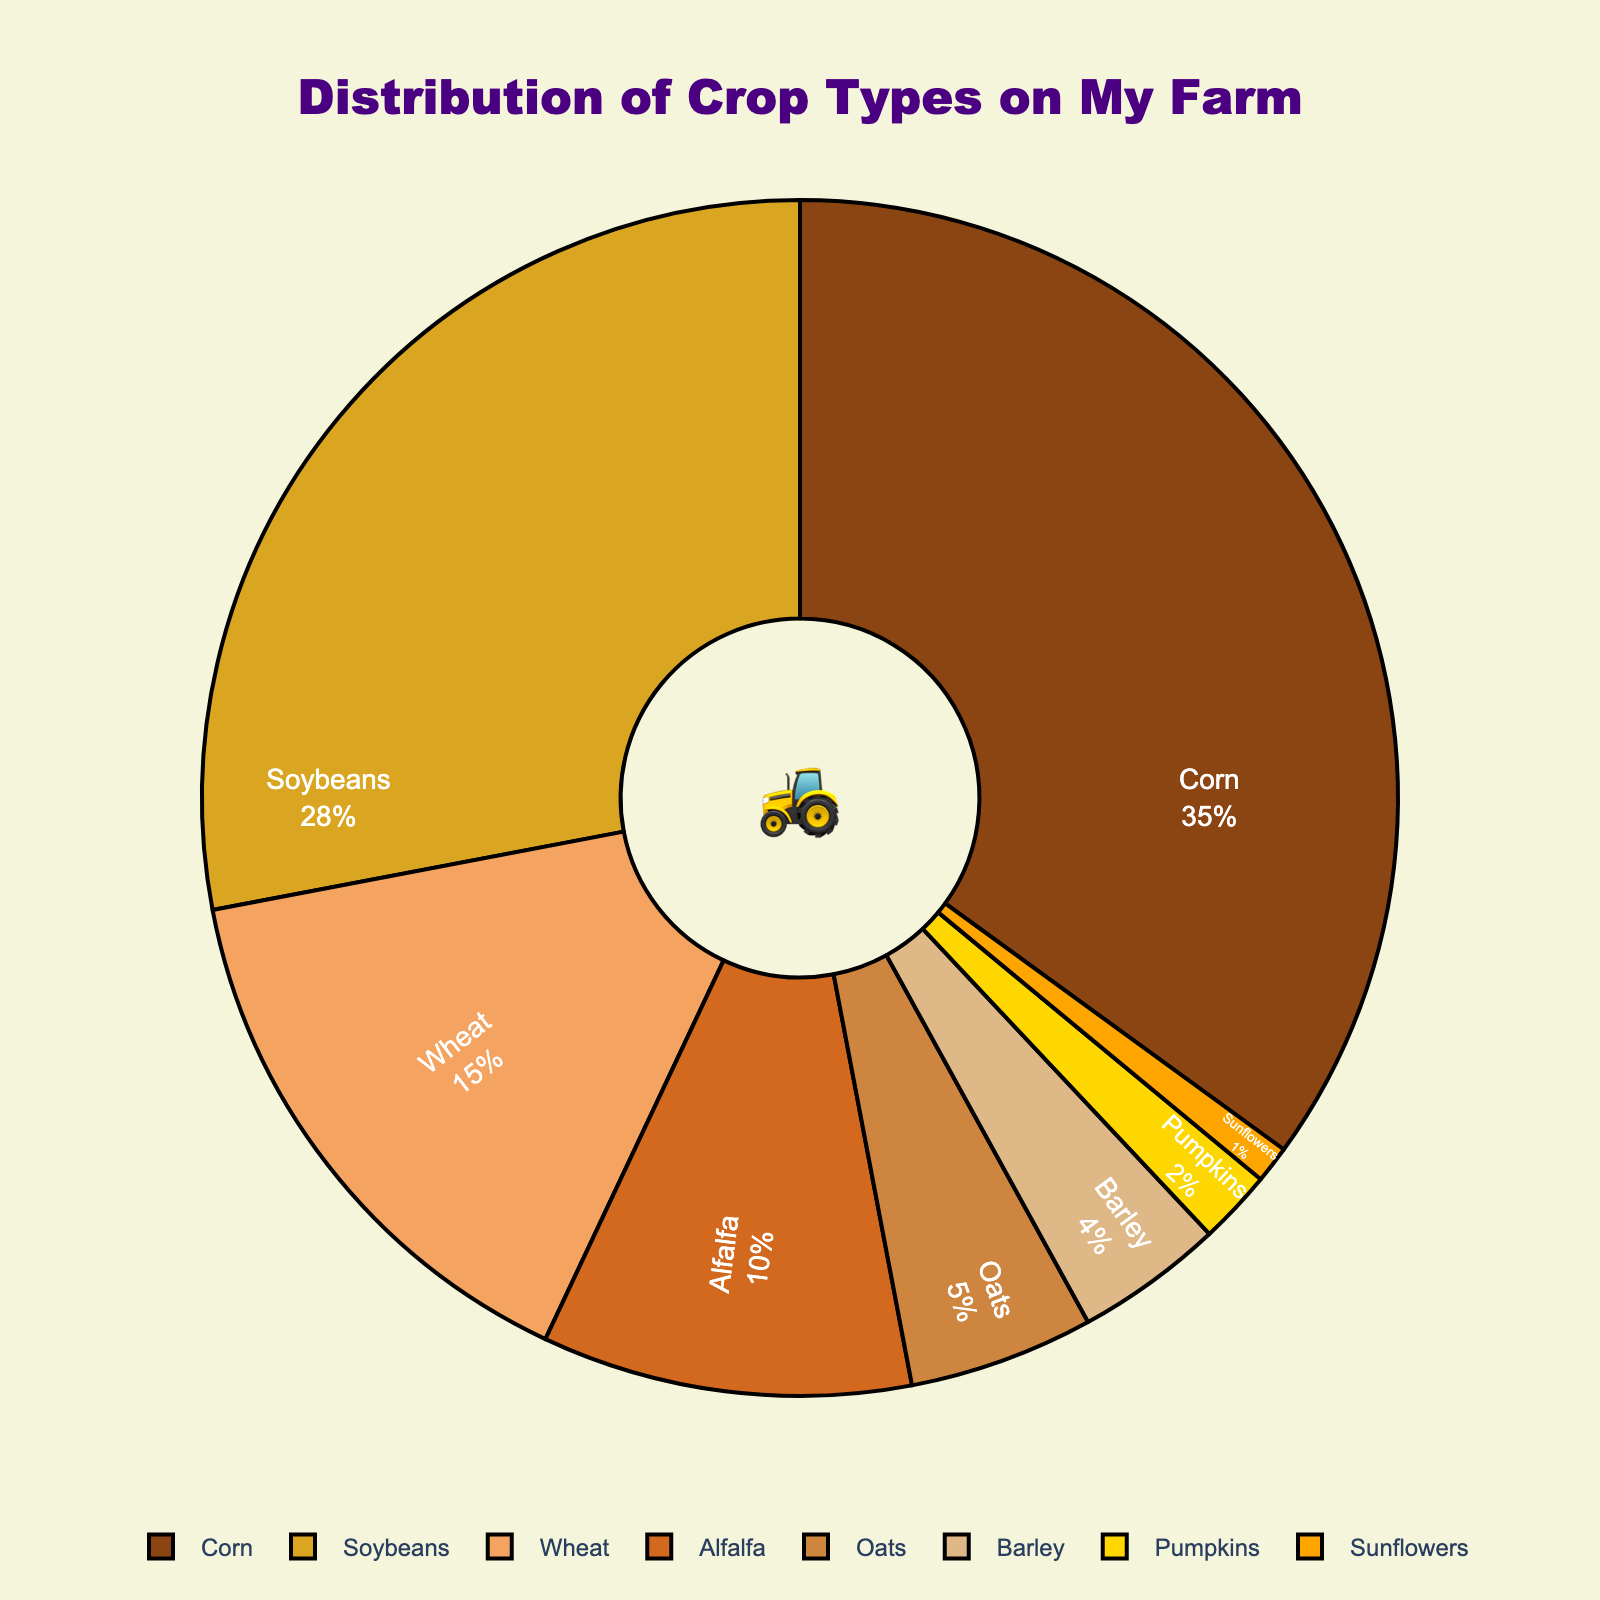what percentage of the crops are wheat and alfalfa combined? To find the combined percentage of wheat and alfalfa, simply add their individual percentages: Wheat (15%) + Alfalfa (10%) = 25%.
Answer: 25% Which crop has the second highest percentage, and what is it? To find the crop with the second highest percentage, view the chart and identify the crop with the highest percentage after Corn. Soybeans has the second highest percentage at 28%.
Answer: Soybeans Which is smaller: the percentage of pumpkins or the percentage of oats? Compare the percentages of pumpkins (2%) and oats (5%). Since 2% is smaller than 5%, pumpkins have the smaller percentage.
Answer: Pumpkins How many crops have a percentage greater than 10%? Count the crops that have percentages greater than 10%: Corn (35%), Soybeans (28%), and Wheat (15%). There are 3 crops with percentages greater than 10%.
Answer: 3 Are all the crops on the farm represented with different colors? By observing the pie chart, each crop slice is colored differently, ensuring each crop has a distinct color.
Answer: Yes 